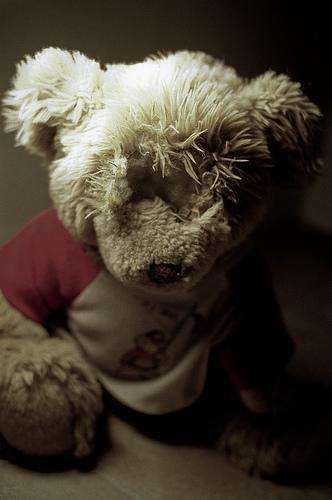How many bears are there?
Give a very brief answer. 1. How many noses does the bear have?
Give a very brief answer. 1. How many teddy bears can you see?
Give a very brief answer. 1. How many cats are visible in the picture?
Give a very brief answer. 0. 